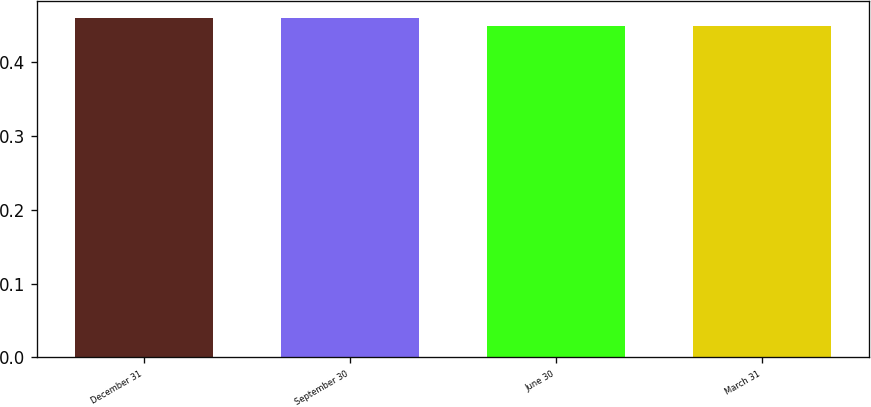Convert chart to OTSL. <chart><loc_0><loc_0><loc_500><loc_500><bar_chart><fcel>December 31<fcel>September 30<fcel>June 30<fcel>March 31<nl><fcel>0.46<fcel>0.46<fcel>0.45<fcel>0.45<nl></chart> 